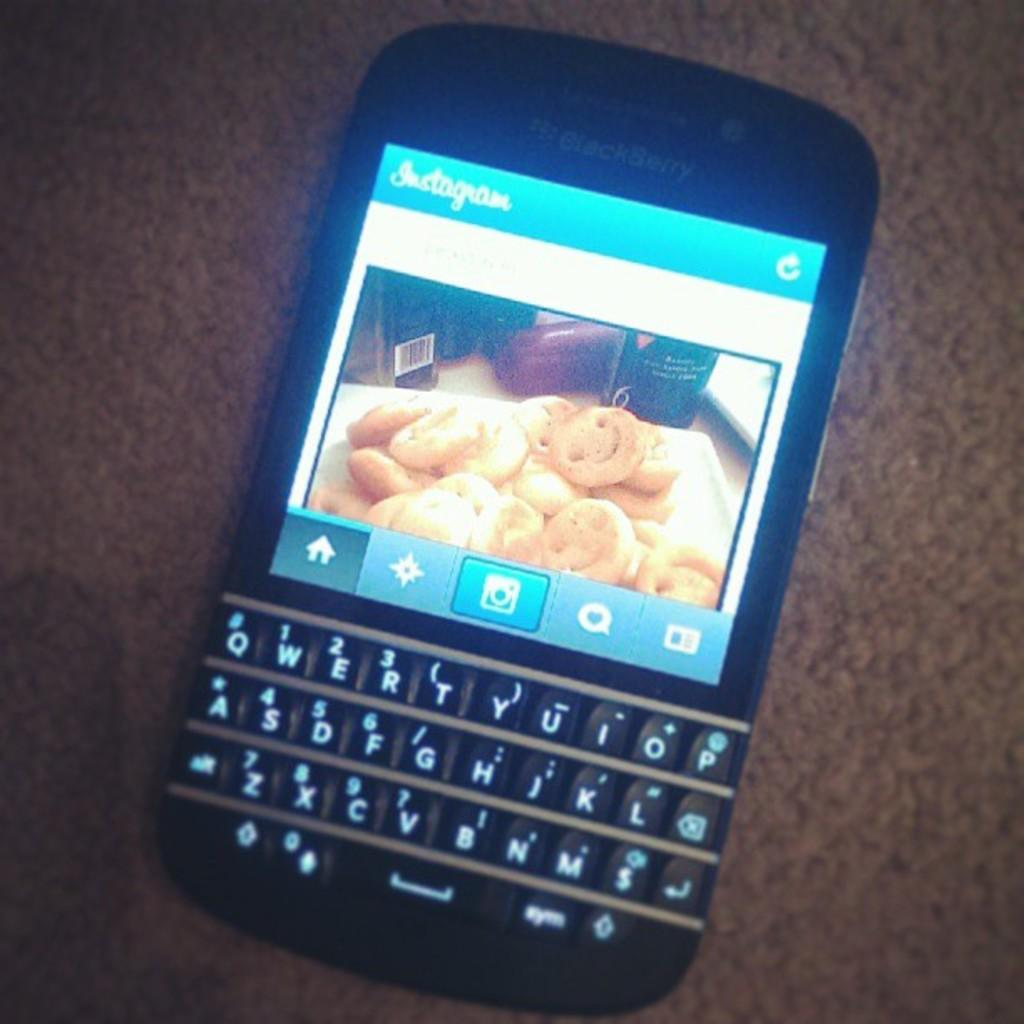Provide a one-sentence caption for the provided image. Blackberry phone shows a picture of cookies on instagram. 